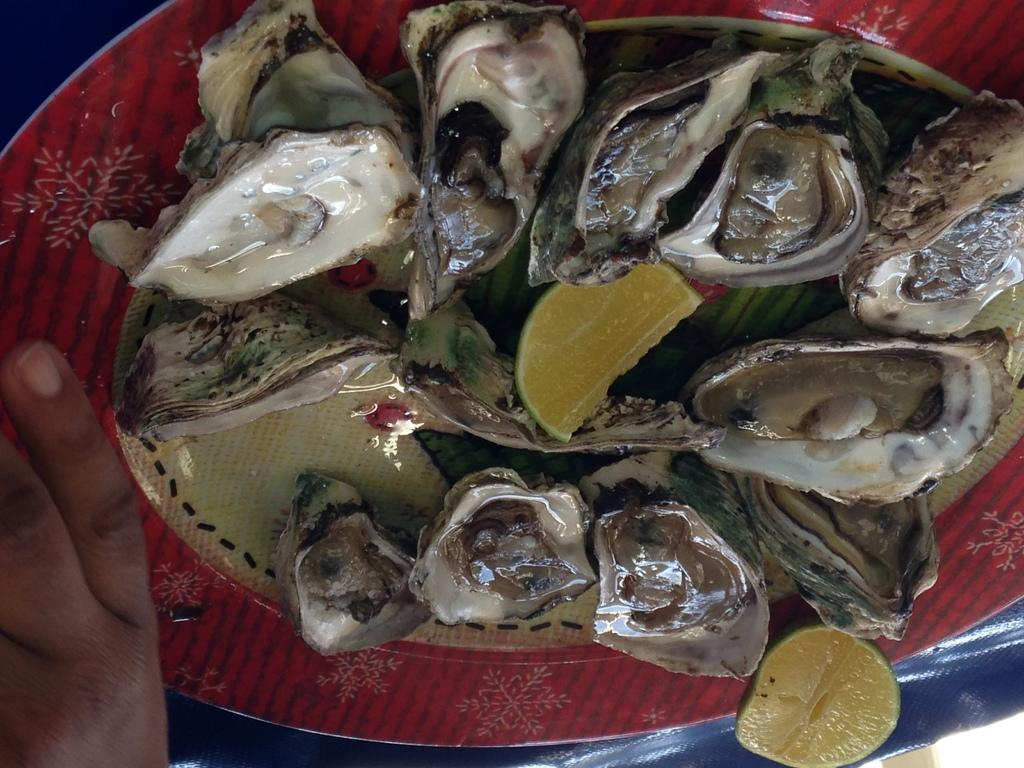What is on the plate that is visible in the image? There is a plate with food items in the image. What is the color of the plate? The plate is red in color. What specific food items can be seen on the plate? There are lemon pieces in the plate. How much oil is present on the plate in the image? There is no oil present on the plate in the image. What type of bottle can be seen next to the plate? There is no bottle present in the image. 